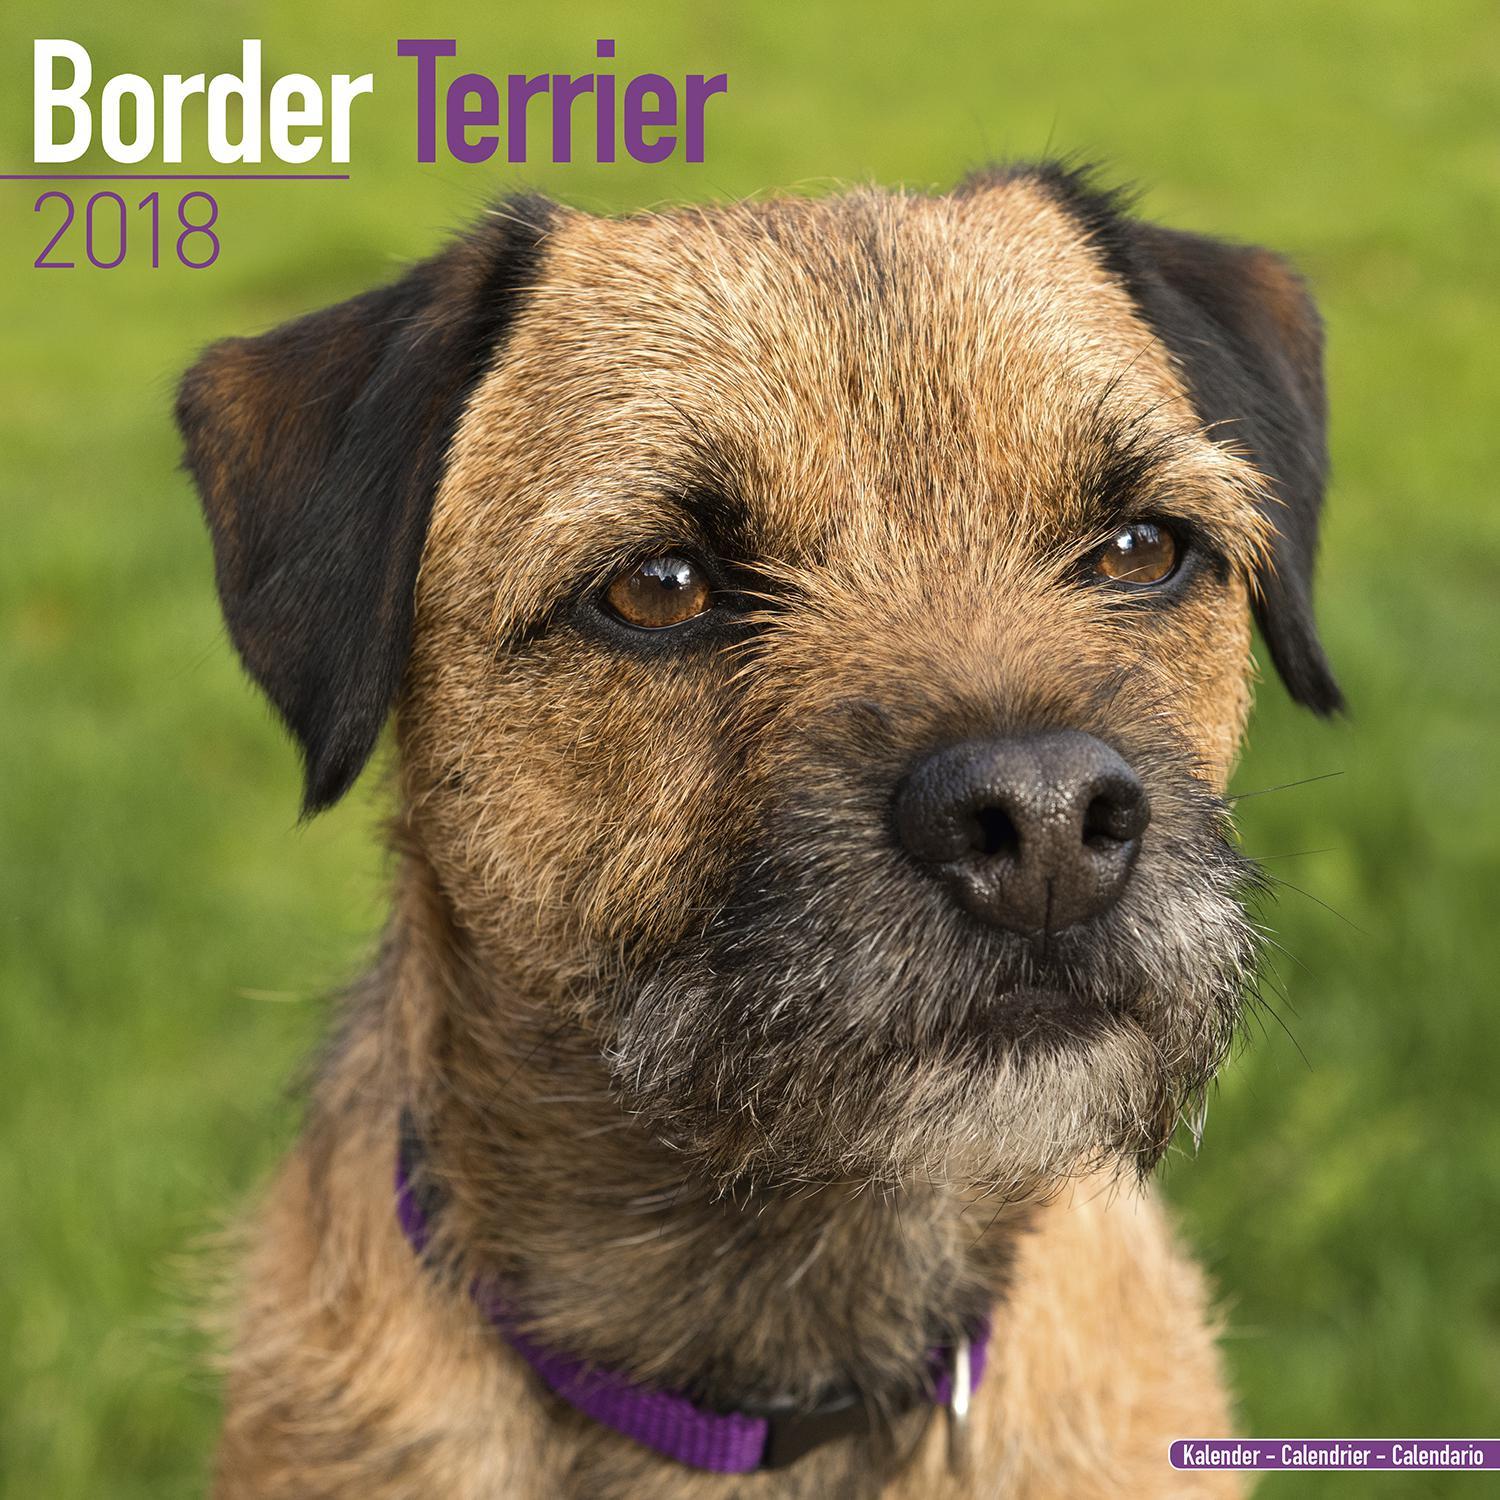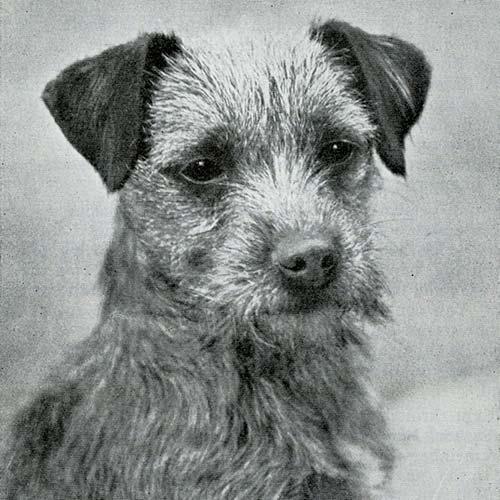The first image is the image on the left, the second image is the image on the right. Analyze the images presented: Is the assertion "The combined images include two dogs with bodies turned rightward in profile, and at least one dog with its head raised and gazing up to the right." valid? Answer yes or no. No. The first image is the image on the left, the second image is the image on the right. For the images shown, is this caption "A dog is standing on grass." true? Answer yes or no. No. 